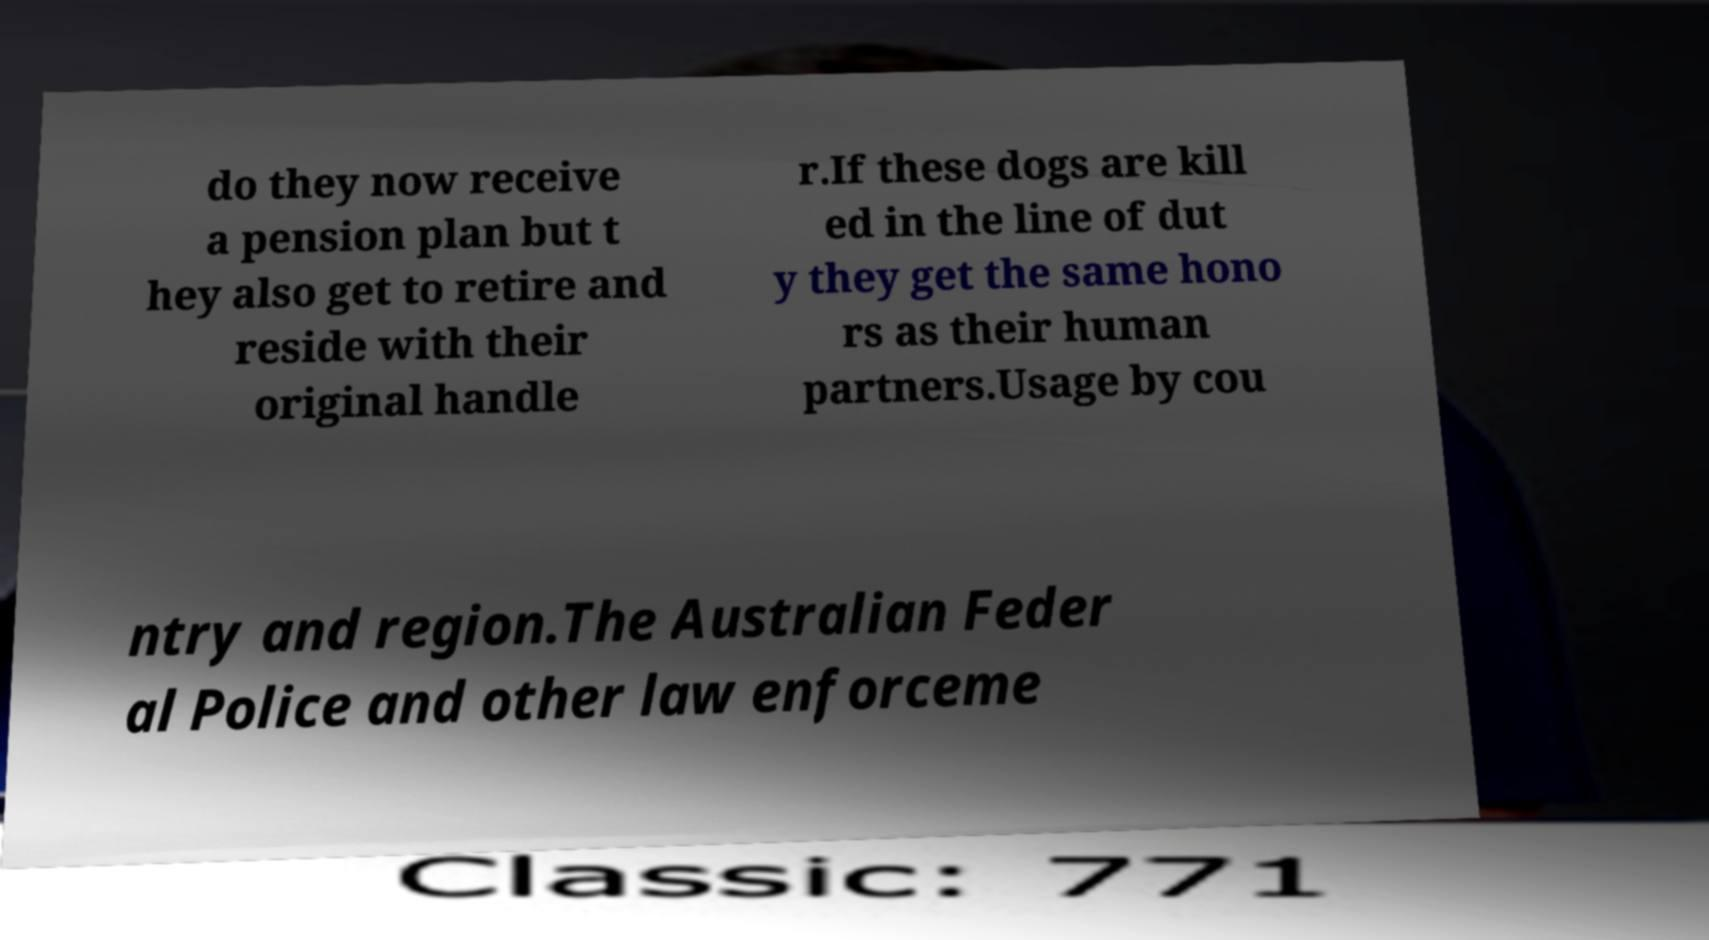Can you read and provide the text displayed in the image?This photo seems to have some interesting text. Can you extract and type it out for me? do they now receive a pension plan but t hey also get to retire and reside with their original handle r.If these dogs are kill ed in the line of dut y they get the same hono rs as their human partners.Usage by cou ntry and region.The Australian Feder al Police and other law enforceme 